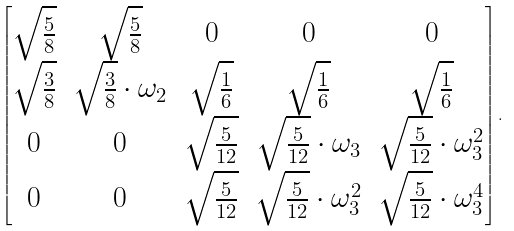Convert formula to latex. <formula><loc_0><loc_0><loc_500><loc_500>\begin{bmatrix} \sqrt { \frac { 5 } { 8 } } & \sqrt { \frac { 5 } { 8 } } & 0 & 0 & 0 \\ \sqrt { \frac { 3 } { 8 } } & \sqrt { \frac { 3 } { 8 } } \cdot \omega _ { 2 } & \sqrt { \frac { 1 } { 6 } } & \sqrt { \frac { 1 } { 6 } } & \sqrt { \frac { 1 } { 6 } } \\ 0 & 0 & \sqrt { \frac { 5 } { 1 2 } } & \sqrt { \frac { 5 } { 1 2 } } \cdot \omega _ { 3 } & \sqrt { \frac { 5 } { 1 2 } } \cdot \omega _ { 3 } ^ { 2 } \\ 0 & 0 & \sqrt { \frac { 5 } { 1 2 } } & \sqrt { \frac { 5 } { 1 2 } } \cdot \omega _ { 3 } ^ { 2 } & \sqrt { \frac { 5 } { 1 2 } } \cdot \omega _ { 3 } ^ { 4 } \\ \end{bmatrix} .</formula> 